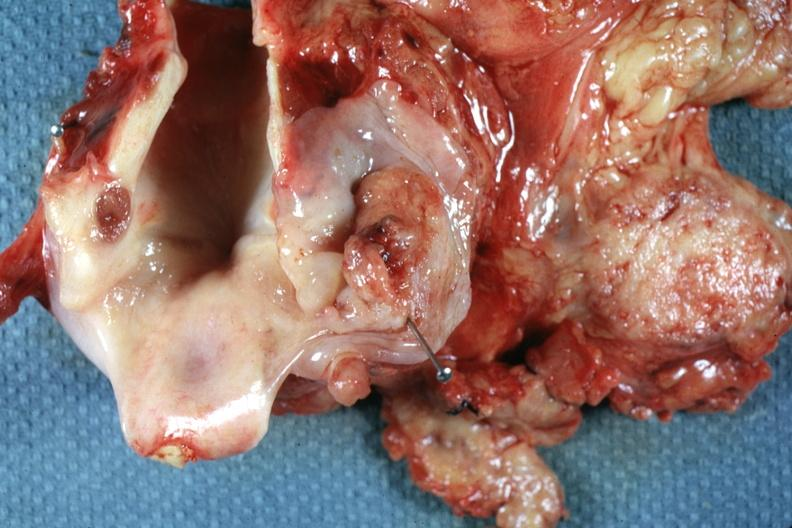does this image show ulcerative lesion right pyriform sinus well shown?
Answer the question using a single word or phrase. Yes 